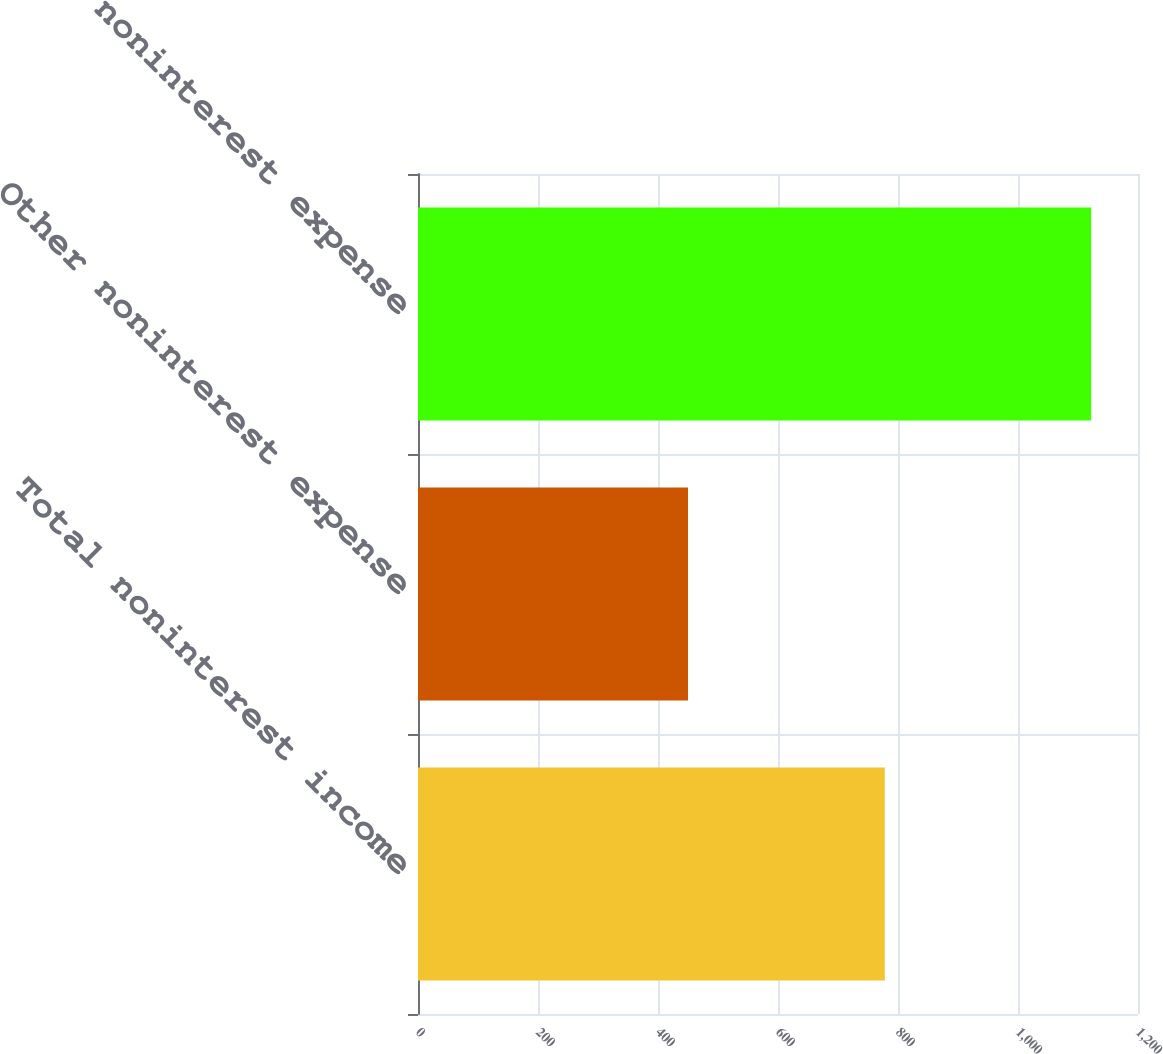Convert chart to OTSL. <chart><loc_0><loc_0><loc_500><loc_500><bar_chart><fcel>Total noninterest income<fcel>Other noninterest expense<fcel>Total noninterest expense<nl><fcel>778<fcel>450<fcel>1122<nl></chart> 